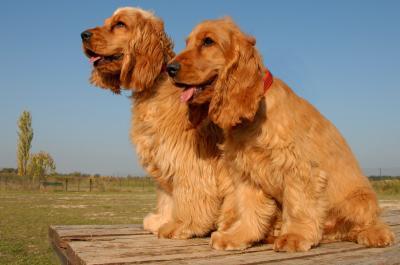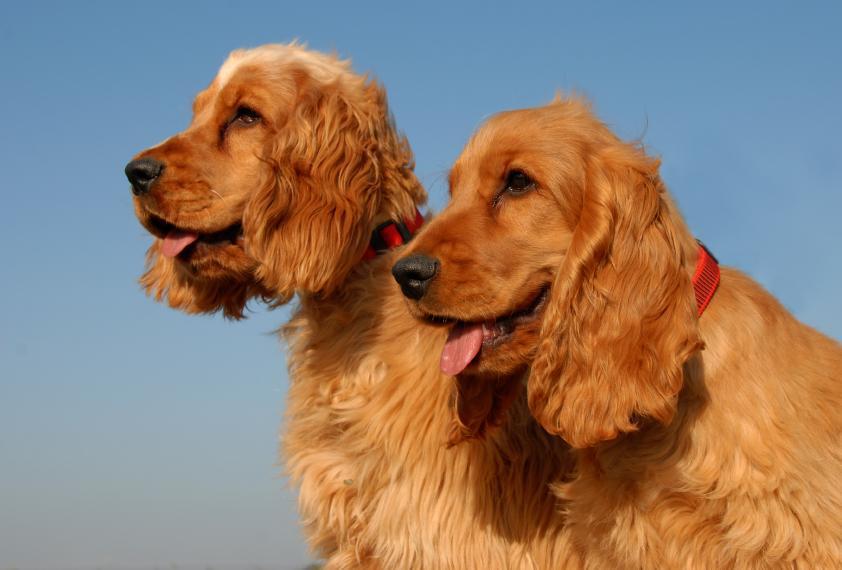The first image is the image on the left, the second image is the image on the right. Assess this claim about the two images: "An image shows one reclining dog with a paw on an object.". Correct or not? Answer yes or no. No. The first image is the image on the left, the second image is the image on the right. Evaluate the accuracy of this statement regarding the images: "There are at least four dogs.". Is it true? Answer yes or no. Yes. 